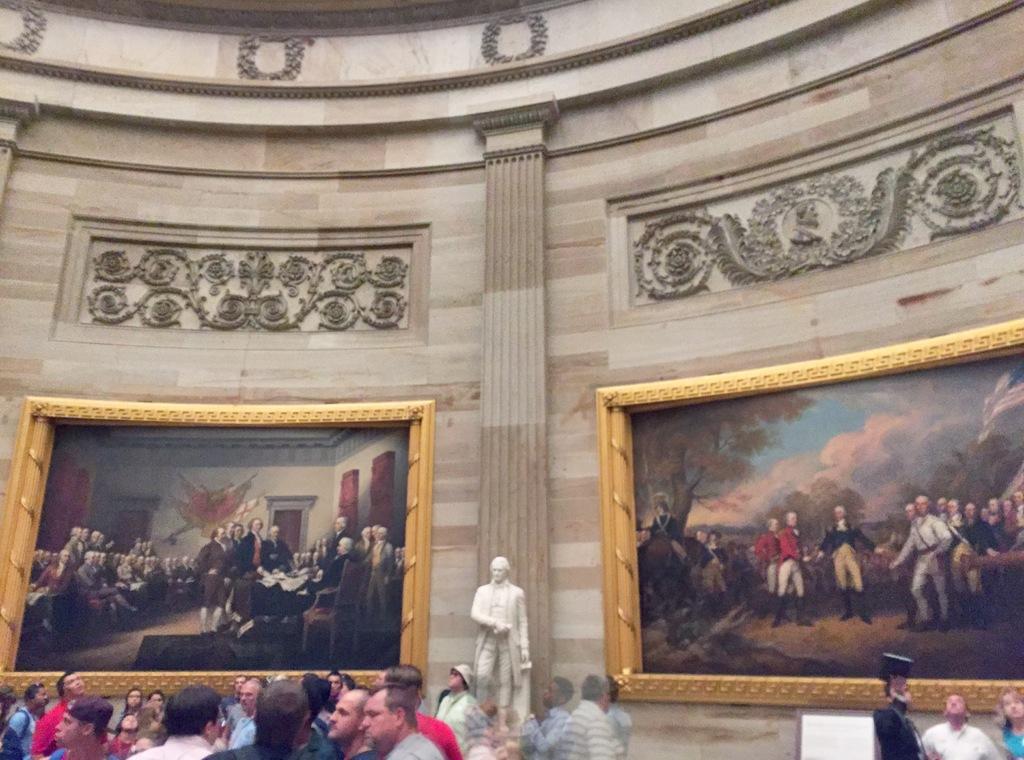What type of artwork can be seen in the image? There are sculptures in the image. What else is present on the walls in the image? There are frames on the wall in the image. Are there any people visible in the image? Yes, there are people visible in the image. What type of lettuce is being discussed by the people in the image? There is no lettuce or discussion present in the image. 